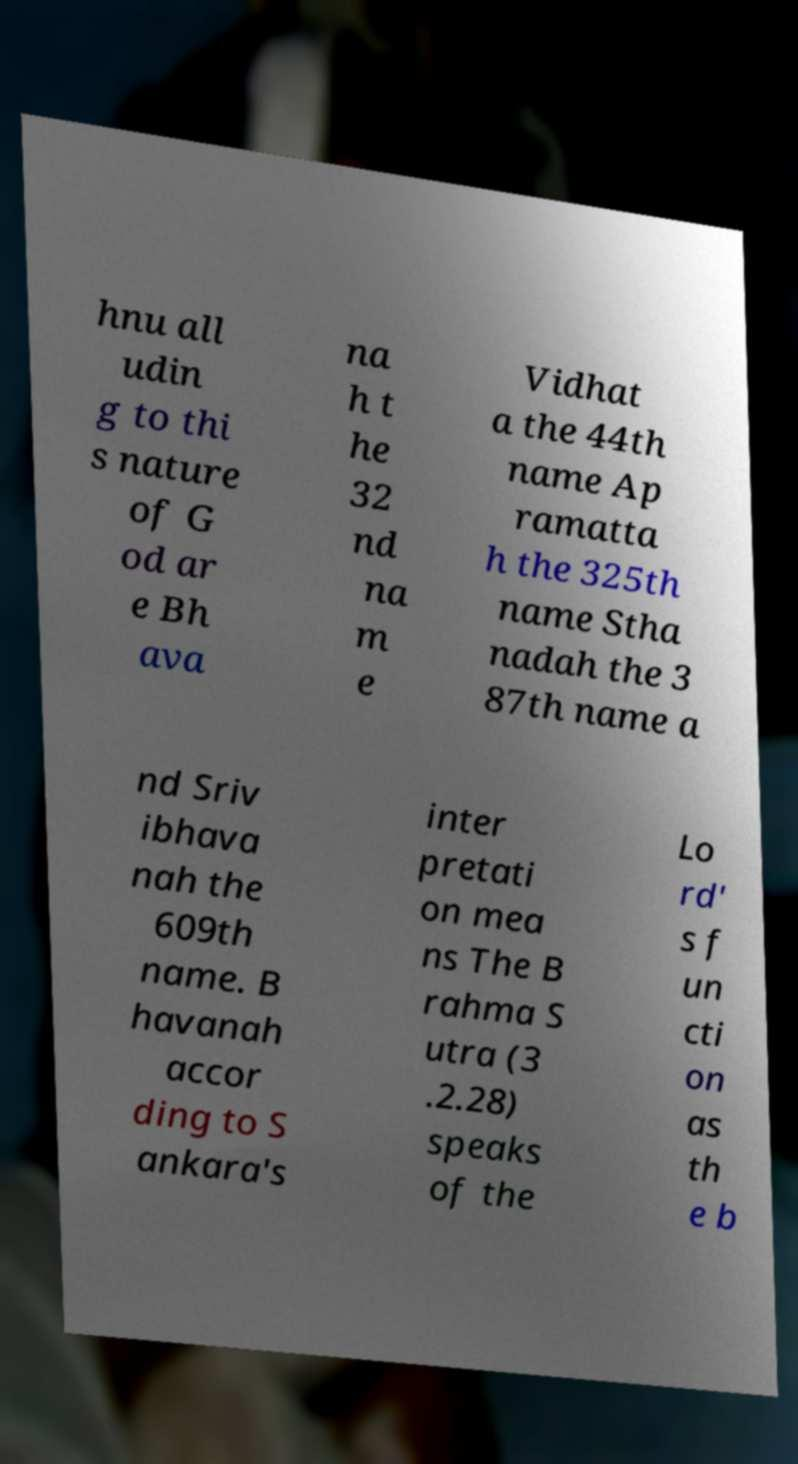There's text embedded in this image that I need extracted. Can you transcribe it verbatim? hnu all udin g to thi s nature of G od ar e Bh ava na h t he 32 nd na m e Vidhat a the 44th name Ap ramatta h the 325th name Stha nadah the 3 87th name a nd Sriv ibhava nah the 609th name. B havanah accor ding to S ankara's inter pretati on mea ns The B rahma S utra (3 .2.28) speaks of the Lo rd' s f un cti on as th e b 